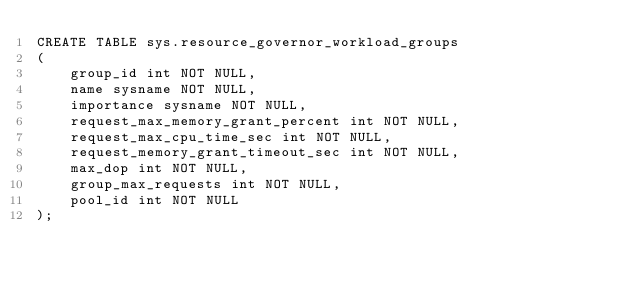<code> <loc_0><loc_0><loc_500><loc_500><_SQL_>CREATE TABLE sys.resource_governor_workload_groups
(
    group_id int NOT NULL,
    name sysname NOT NULL,
    importance sysname NOT NULL,
    request_max_memory_grant_percent int NOT NULL,
    request_max_cpu_time_sec int NOT NULL,
    request_memory_grant_timeout_sec int NOT NULL,
    max_dop int NOT NULL,
    group_max_requests int NOT NULL,
    pool_id int NOT NULL
);</code> 